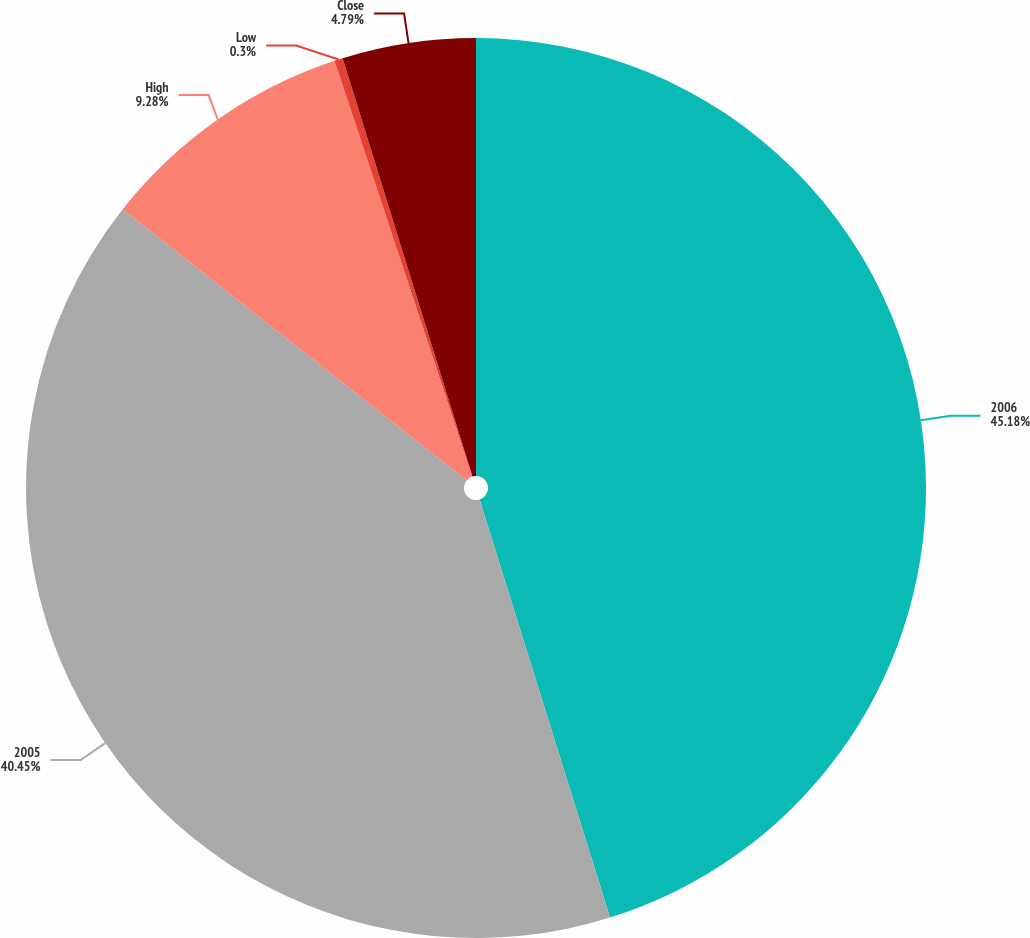Convert chart to OTSL. <chart><loc_0><loc_0><loc_500><loc_500><pie_chart><fcel>2006<fcel>2005<fcel>High<fcel>Low<fcel>Close<nl><fcel>45.19%<fcel>40.45%<fcel>9.28%<fcel>0.3%<fcel>4.79%<nl></chart> 